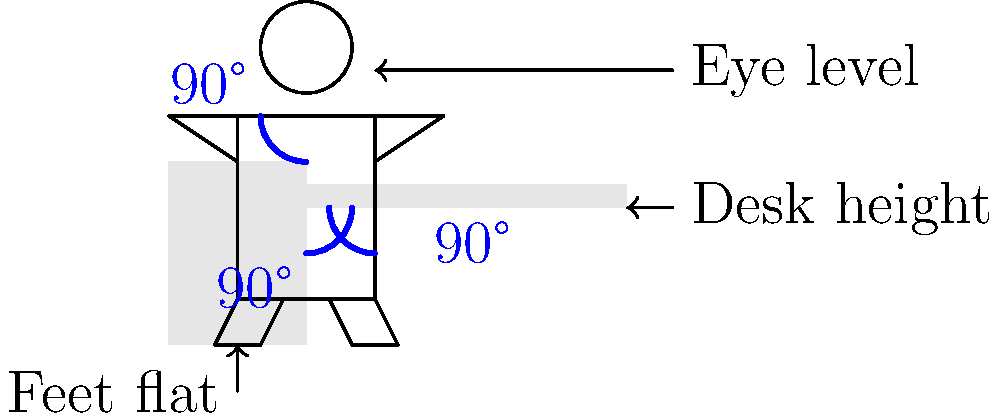As a union leader advocating for employee well-being, you're reviewing a proposed ergonomic workplace design. The diagram shows recommended sitting posture. What are the three critical 90-degree angles that should be maintained for optimal ergonomics, and why are they important for employee health and productivity? To answer this question, let's analyze the diagram and understand the importance of proper ergonomic posture:

1. First 90-degree angle: At the hips
   - This angle is formed between the torso and thighs.
   - Importance: Maintains proper spinal alignment, reducing lower back strain.

2. Second 90-degree angle: At the knees
   - This angle is formed between the thighs and lower legs.
   - Importance: Promotes good circulation in the legs and reduces pressure on the thighs.

3. Third 90-degree angle: At the elbows
   - This angle is formed when the arms are resting on the desk.
   - Importance: Reduces strain on the shoulders and upper back, preventing repetitive stress injuries.

These angles are crucial for employee health and productivity because:

a) They promote proper spinal alignment, reducing the risk of back pain and long-term spinal issues.
b) They help maintain good circulation, preventing fatigue and discomfort during long periods of sitting.
c) They minimize the risk of repetitive stress injuries, such as carpal tunnel syndrome.
d) Proper posture can increase focus and productivity by reducing physical discomfort and distraction.
e) Long-term adherence to ergonomic principles can lead to fewer work-related injuries and lower healthcare costs for both employees and the company.

As a union leader, emphasizing these ergonomic principles can lead to improved working conditions, higher job satisfaction, and potentially reduced absenteeism due to work-related injuries.
Answer: Hips, knees, and elbows at 90 degrees; promotes spinal alignment, circulation, and reduces strain. 